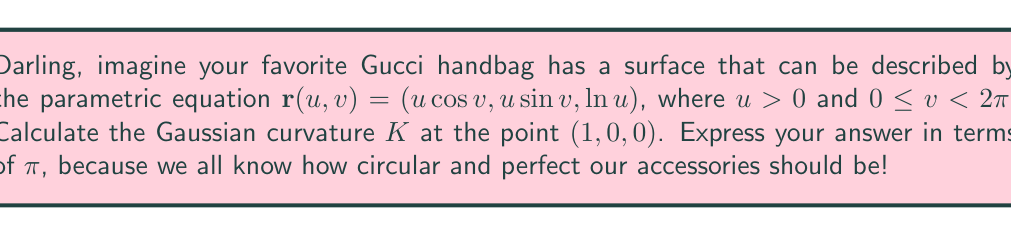Could you help me with this problem? To find the Gaussian curvature, we'll follow these fabulous steps:

1) First, we need to calculate the first fundamental form coefficients:
   $E = \mathbf{r}_u \cdot \mathbf{r}_u$, $F = \mathbf{r}_u \cdot \mathbf{r}_v$, $G = \mathbf{r}_v \cdot \mathbf{r}_v$

   $\mathbf{r}_u = (\cos v, \sin v, \frac{1}{u})$
   $\mathbf{r}_v = (-u\sin v, u\cos v, 0)$

   $E = \cos^2 v + \sin^2 v + \frac{1}{u^2} = 1 + \frac{1}{u^2}$
   $F = -u\sin v \cos v + u\sin v \cos v = 0$
   $G = u^2\sin^2 v + u^2\cos^2 v = u^2$

2) Now, let's calculate the second fundamental form coefficients:
   $L = \mathbf{r}_{uu} \cdot \mathbf{n}$, $M = \mathbf{r}_{uv} \cdot \mathbf{n}$, $N = \mathbf{r}_{vv} \cdot \mathbf{n}$

   Where $\mathbf{n}$ is the unit normal vector:
   $\mathbf{n} = \frac{\mathbf{r}_u \times \mathbf{r}_v}{|\mathbf{r}_u \times \mathbf{r}_v|}$

   $\mathbf{r}_u \times \mathbf{r}_v = (u\sin v, -u\cos v, u)$
   $|\mathbf{r}_u \times \mathbf{r}_v| = u\sqrt{1 + \frac{1}{u^2}}$

   $\mathbf{n} = (\frac{\sin v}{\sqrt{1 + \frac{1}{u^2}}}, -\frac{\cos v}{\sqrt{1 + \frac{1}{u^2}}}, \frac{1}{u\sqrt{1 + \frac{1}{u^2}}})$

   $\mathbf{r}_{uu} = (0, 0, -\frac{1}{u^2})$
   $\mathbf{r}_{uv} = (-\sin v, \cos v, 0)$
   $\mathbf{r}_{vv} = (-u\cos v, -u\sin v, 0)$

   $L = -\frac{1}{u^3\sqrt{1 + \frac{1}{u^2}}}$
   $M = 0$
   $N = -\frac{u}{\sqrt{1 + \frac{1}{u^2}}}$

3) The Gaussian curvature is given by:
   $K = \frac{LN - M^2}{EG - F^2}$

4) At the point $(1, 0, 0)$, we have $u = 1$, $v = 0$:

   $E = 2$, $F = 0$, $G = 1$
   $L = -\frac{1}{\sqrt{2}}$, $M = 0$, $N = -\frac{1}{\sqrt{2}}$

5) Substituting these values:

   $K = \frac{(-\frac{1}{\sqrt{2}})(-\frac{1}{\sqrt{2}}) - 0^2}{2(1) - 0^2} = \frac{1/2}{2} = \frac{1}{4}$

6) To express this in terms of $\pi$, we can write:

   $K = \frac{1}{4} = \frac{\pi}{4\pi}$
Answer: $\frac{\pi}{4\pi}$ 